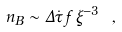<formula> <loc_0><loc_0><loc_500><loc_500>n _ { B } \sim \Delta \dot { \tau } \, f \, \xi ^ { - 3 } \ ,</formula> 